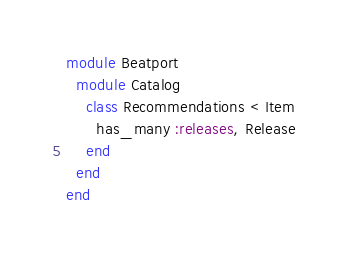<code> <loc_0><loc_0><loc_500><loc_500><_Ruby_>module Beatport
  module Catalog  
    class Recommendations < Item
      has_many :releases, Release
    end
  end
end</code> 